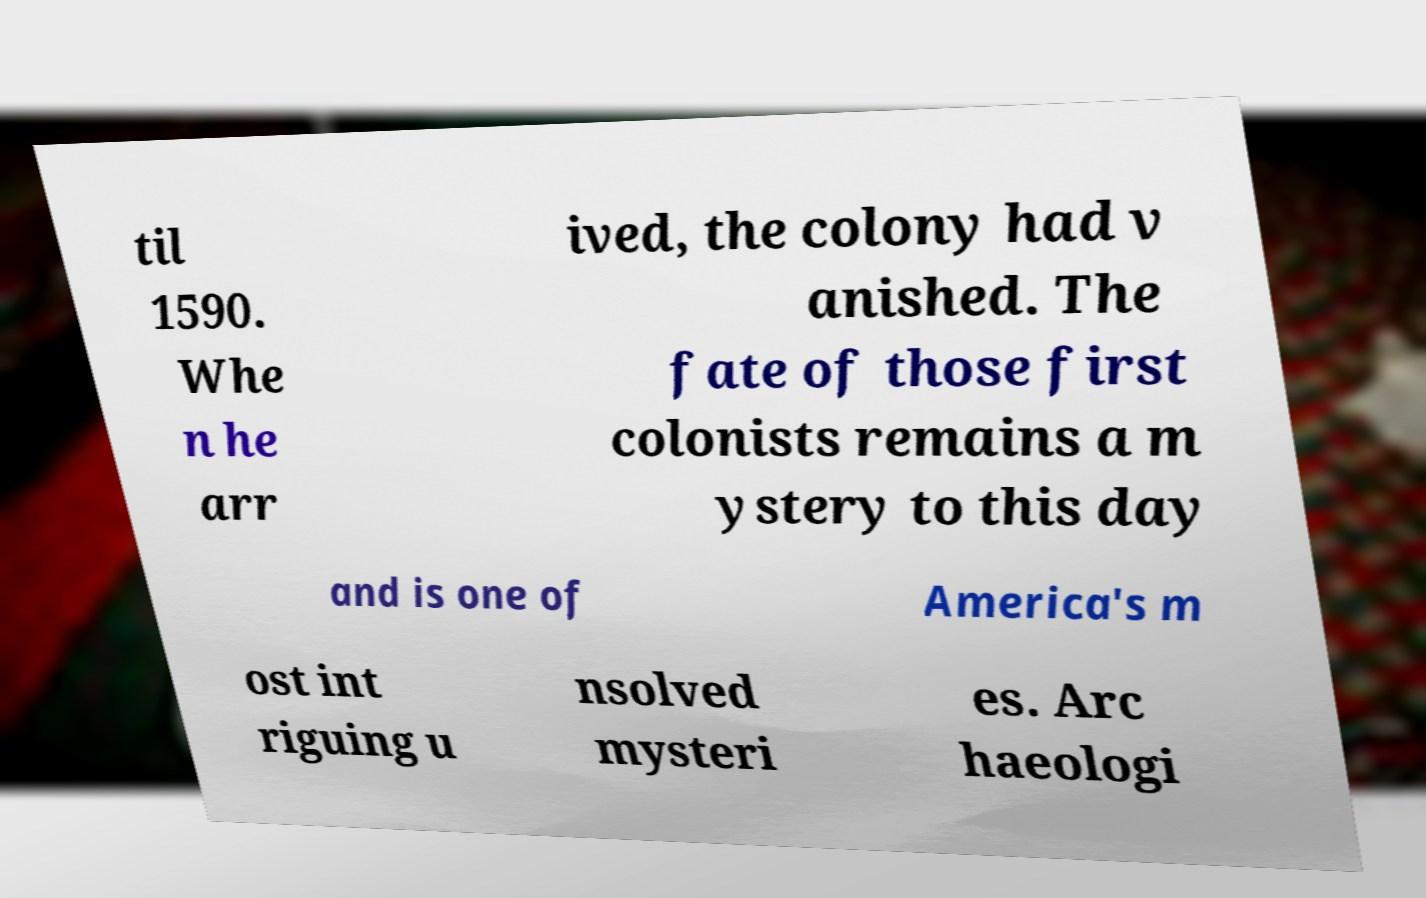Please read and relay the text visible in this image. What does it say? til 1590. Whe n he arr ived, the colony had v anished. The fate of those first colonists remains a m ystery to this day and is one of America's m ost int riguing u nsolved mysteri es. Arc haeologi 